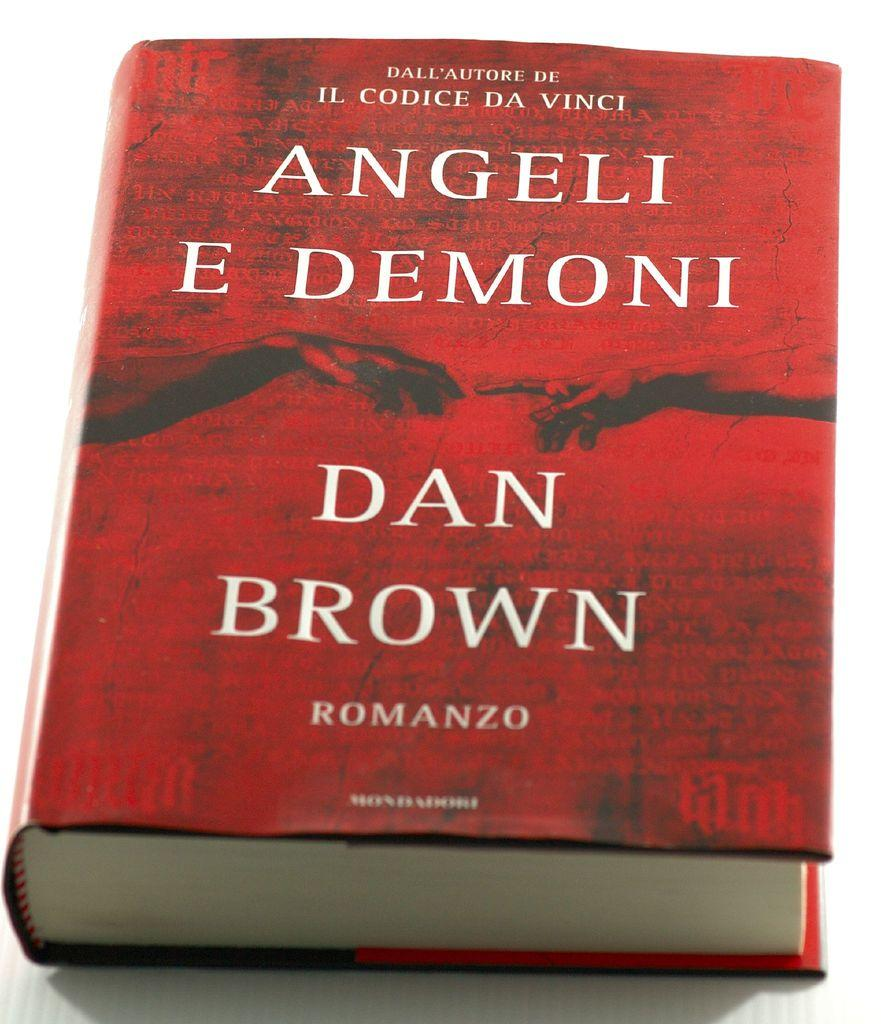Provide a one-sentence caption for the provided image. A hardcover red book written by Dan Brown. 